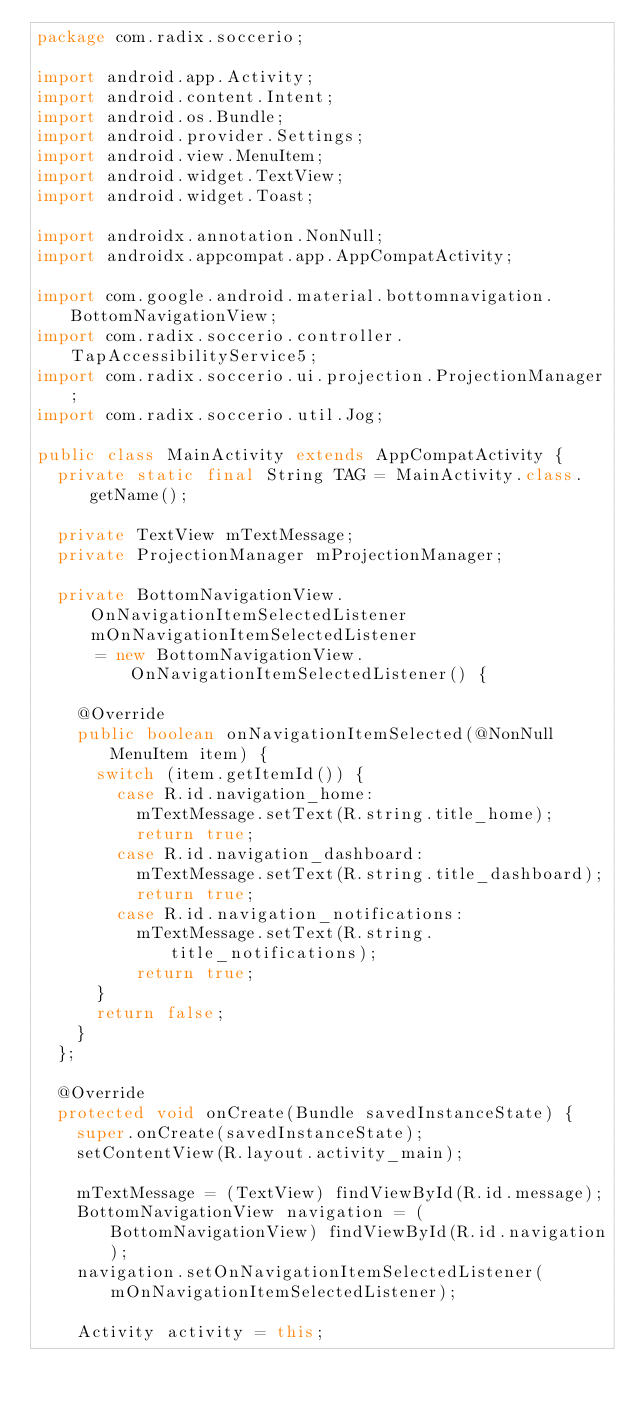<code> <loc_0><loc_0><loc_500><loc_500><_Java_>package com.radix.soccerio;

import android.app.Activity;
import android.content.Intent;
import android.os.Bundle;
import android.provider.Settings;
import android.view.MenuItem;
import android.widget.TextView;
import android.widget.Toast;

import androidx.annotation.NonNull;
import androidx.appcompat.app.AppCompatActivity;

import com.google.android.material.bottomnavigation.BottomNavigationView;
import com.radix.soccerio.controller.TapAccessibilityService5;
import com.radix.soccerio.ui.projection.ProjectionManager;
import com.radix.soccerio.util.Jog;

public class MainActivity extends AppCompatActivity {
  private static final String TAG = MainActivity.class.getName();

  private TextView mTextMessage;
  private ProjectionManager mProjectionManager;

  private BottomNavigationView.OnNavigationItemSelectedListener mOnNavigationItemSelectedListener
      = new BottomNavigationView.OnNavigationItemSelectedListener() {

    @Override
    public boolean onNavigationItemSelected(@NonNull MenuItem item) {
      switch (item.getItemId()) {
        case R.id.navigation_home:
          mTextMessage.setText(R.string.title_home);
          return true;
        case R.id.navigation_dashboard:
          mTextMessage.setText(R.string.title_dashboard);
          return true;
        case R.id.navigation_notifications:
          mTextMessage.setText(R.string.title_notifications);
          return true;
      }
      return false;
    }
  };

  @Override
  protected void onCreate(Bundle savedInstanceState) {
    super.onCreate(savedInstanceState);
    setContentView(R.layout.activity_main);

    mTextMessage = (TextView) findViewById(R.id.message);
    BottomNavigationView navigation = (BottomNavigationView) findViewById(R.id.navigation);
    navigation.setOnNavigationItemSelectedListener(mOnNavigationItemSelectedListener);

    Activity activity = this;</code> 